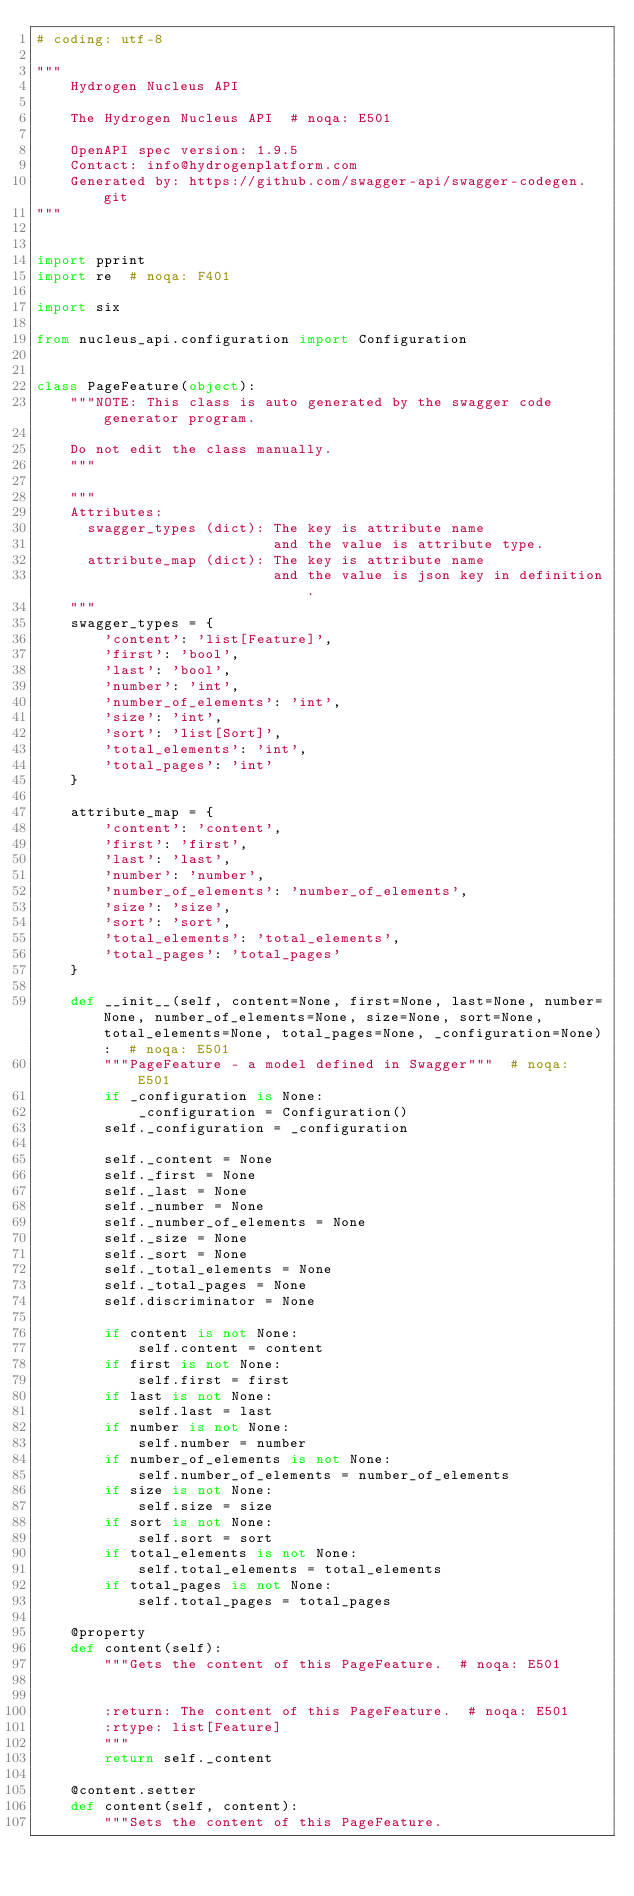Convert code to text. <code><loc_0><loc_0><loc_500><loc_500><_Python_># coding: utf-8

"""
    Hydrogen Nucleus API

    The Hydrogen Nucleus API  # noqa: E501

    OpenAPI spec version: 1.9.5
    Contact: info@hydrogenplatform.com
    Generated by: https://github.com/swagger-api/swagger-codegen.git
"""


import pprint
import re  # noqa: F401

import six

from nucleus_api.configuration import Configuration


class PageFeature(object):
    """NOTE: This class is auto generated by the swagger code generator program.

    Do not edit the class manually.
    """

    """
    Attributes:
      swagger_types (dict): The key is attribute name
                            and the value is attribute type.
      attribute_map (dict): The key is attribute name
                            and the value is json key in definition.
    """
    swagger_types = {
        'content': 'list[Feature]',
        'first': 'bool',
        'last': 'bool',
        'number': 'int',
        'number_of_elements': 'int',
        'size': 'int',
        'sort': 'list[Sort]',
        'total_elements': 'int',
        'total_pages': 'int'
    }

    attribute_map = {
        'content': 'content',
        'first': 'first',
        'last': 'last',
        'number': 'number',
        'number_of_elements': 'number_of_elements',
        'size': 'size',
        'sort': 'sort',
        'total_elements': 'total_elements',
        'total_pages': 'total_pages'
    }

    def __init__(self, content=None, first=None, last=None, number=None, number_of_elements=None, size=None, sort=None, total_elements=None, total_pages=None, _configuration=None):  # noqa: E501
        """PageFeature - a model defined in Swagger"""  # noqa: E501
        if _configuration is None:
            _configuration = Configuration()
        self._configuration = _configuration

        self._content = None
        self._first = None
        self._last = None
        self._number = None
        self._number_of_elements = None
        self._size = None
        self._sort = None
        self._total_elements = None
        self._total_pages = None
        self.discriminator = None

        if content is not None:
            self.content = content
        if first is not None:
            self.first = first
        if last is not None:
            self.last = last
        if number is not None:
            self.number = number
        if number_of_elements is not None:
            self.number_of_elements = number_of_elements
        if size is not None:
            self.size = size
        if sort is not None:
            self.sort = sort
        if total_elements is not None:
            self.total_elements = total_elements
        if total_pages is not None:
            self.total_pages = total_pages

    @property
    def content(self):
        """Gets the content of this PageFeature.  # noqa: E501


        :return: The content of this PageFeature.  # noqa: E501
        :rtype: list[Feature]
        """
        return self._content

    @content.setter
    def content(self, content):
        """Sets the content of this PageFeature.

</code> 